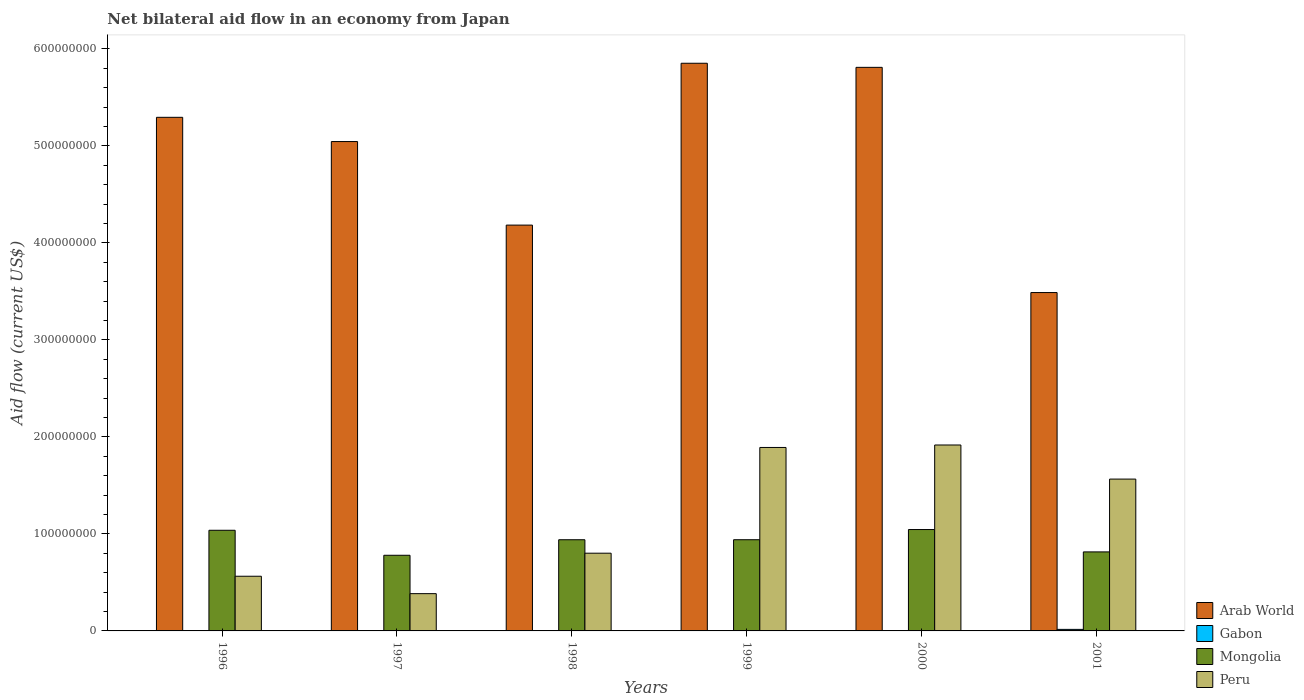How many different coloured bars are there?
Give a very brief answer. 4. How many groups of bars are there?
Offer a terse response. 6. Are the number of bars per tick equal to the number of legend labels?
Offer a very short reply. No. How many bars are there on the 6th tick from the left?
Keep it short and to the point. 4. What is the label of the 3rd group of bars from the left?
Keep it short and to the point. 1998. In how many cases, is the number of bars for a given year not equal to the number of legend labels?
Your answer should be compact. 1. What is the net bilateral aid flow in Mongolia in 1997?
Your answer should be compact. 7.80e+07. Across all years, what is the maximum net bilateral aid flow in Mongolia?
Offer a terse response. 1.05e+08. Across all years, what is the minimum net bilateral aid flow in Gabon?
Your answer should be very brief. 0. What is the total net bilateral aid flow in Gabon in the graph?
Offer a terse response. 2.82e+06. What is the difference between the net bilateral aid flow in Peru in 1997 and that in 2001?
Your response must be concise. -1.18e+08. What is the difference between the net bilateral aid flow in Peru in 1996 and the net bilateral aid flow in Mongolia in 1999?
Keep it short and to the point. -3.76e+07. In the year 1998, what is the difference between the net bilateral aid flow in Gabon and net bilateral aid flow in Arab World?
Offer a terse response. -4.18e+08. In how many years, is the net bilateral aid flow in Arab World greater than 400000000 US$?
Give a very brief answer. 5. What is the ratio of the net bilateral aid flow in Gabon in 1996 to that in 1997?
Your answer should be very brief. 0.62. Is the net bilateral aid flow in Arab World in 1998 less than that in 1999?
Provide a short and direct response. Yes. Is the difference between the net bilateral aid flow in Gabon in 1997 and 1999 greater than the difference between the net bilateral aid flow in Arab World in 1997 and 1999?
Your answer should be very brief. Yes. What is the difference between the highest and the second highest net bilateral aid flow in Gabon?
Keep it short and to the point. 1.19e+06. What is the difference between the highest and the lowest net bilateral aid flow in Mongolia?
Your response must be concise. 2.65e+07. Is it the case that in every year, the sum of the net bilateral aid flow in Mongolia and net bilateral aid flow in Arab World is greater than the sum of net bilateral aid flow in Gabon and net bilateral aid flow in Peru?
Offer a very short reply. No. Is it the case that in every year, the sum of the net bilateral aid flow in Gabon and net bilateral aid flow in Mongolia is greater than the net bilateral aid flow in Arab World?
Your response must be concise. No. How many bars are there?
Make the answer very short. 23. How many years are there in the graph?
Provide a short and direct response. 6. Does the graph contain grids?
Make the answer very short. No. Where does the legend appear in the graph?
Ensure brevity in your answer.  Bottom right. How many legend labels are there?
Your answer should be very brief. 4. What is the title of the graph?
Provide a short and direct response. Net bilateral aid flow in an economy from Japan. Does "Cabo Verde" appear as one of the legend labels in the graph?
Your answer should be compact. No. What is the label or title of the X-axis?
Keep it short and to the point. Years. What is the Aid flow (current US$) in Arab World in 1996?
Provide a succinct answer. 5.29e+08. What is the Aid flow (current US$) in Gabon in 1996?
Your answer should be compact. 2.40e+05. What is the Aid flow (current US$) of Mongolia in 1996?
Ensure brevity in your answer.  1.04e+08. What is the Aid flow (current US$) in Peru in 1996?
Give a very brief answer. 5.64e+07. What is the Aid flow (current US$) of Arab World in 1997?
Ensure brevity in your answer.  5.04e+08. What is the Aid flow (current US$) in Gabon in 1997?
Keep it short and to the point. 3.90e+05. What is the Aid flow (current US$) of Mongolia in 1997?
Keep it short and to the point. 7.80e+07. What is the Aid flow (current US$) in Peru in 1997?
Offer a terse response. 3.84e+07. What is the Aid flow (current US$) in Arab World in 1998?
Ensure brevity in your answer.  4.18e+08. What is the Aid flow (current US$) of Gabon in 1998?
Keep it short and to the point. 2.80e+05. What is the Aid flow (current US$) of Mongolia in 1998?
Keep it short and to the point. 9.40e+07. What is the Aid flow (current US$) of Peru in 1998?
Your answer should be very brief. 8.01e+07. What is the Aid flow (current US$) of Arab World in 1999?
Make the answer very short. 5.85e+08. What is the Aid flow (current US$) in Gabon in 1999?
Your answer should be very brief. 3.30e+05. What is the Aid flow (current US$) in Mongolia in 1999?
Ensure brevity in your answer.  9.40e+07. What is the Aid flow (current US$) in Peru in 1999?
Make the answer very short. 1.89e+08. What is the Aid flow (current US$) of Arab World in 2000?
Provide a succinct answer. 5.81e+08. What is the Aid flow (current US$) in Gabon in 2000?
Provide a short and direct response. 0. What is the Aid flow (current US$) of Mongolia in 2000?
Provide a succinct answer. 1.05e+08. What is the Aid flow (current US$) of Peru in 2000?
Give a very brief answer. 1.92e+08. What is the Aid flow (current US$) of Arab World in 2001?
Ensure brevity in your answer.  3.49e+08. What is the Aid flow (current US$) of Gabon in 2001?
Ensure brevity in your answer.  1.58e+06. What is the Aid flow (current US$) in Mongolia in 2001?
Keep it short and to the point. 8.15e+07. What is the Aid flow (current US$) in Peru in 2001?
Make the answer very short. 1.57e+08. Across all years, what is the maximum Aid flow (current US$) of Arab World?
Your answer should be very brief. 5.85e+08. Across all years, what is the maximum Aid flow (current US$) of Gabon?
Offer a very short reply. 1.58e+06. Across all years, what is the maximum Aid flow (current US$) of Mongolia?
Offer a terse response. 1.05e+08. Across all years, what is the maximum Aid flow (current US$) of Peru?
Provide a short and direct response. 1.92e+08. Across all years, what is the minimum Aid flow (current US$) in Arab World?
Your response must be concise. 3.49e+08. Across all years, what is the minimum Aid flow (current US$) of Mongolia?
Ensure brevity in your answer.  7.80e+07. Across all years, what is the minimum Aid flow (current US$) of Peru?
Offer a terse response. 3.84e+07. What is the total Aid flow (current US$) in Arab World in the graph?
Make the answer very short. 2.97e+09. What is the total Aid flow (current US$) of Gabon in the graph?
Make the answer very short. 2.82e+06. What is the total Aid flow (current US$) of Mongolia in the graph?
Your answer should be very brief. 5.56e+08. What is the total Aid flow (current US$) in Peru in the graph?
Provide a short and direct response. 7.12e+08. What is the difference between the Aid flow (current US$) in Arab World in 1996 and that in 1997?
Give a very brief answer. 2.50e+07. What is the difference between the Aid flow (current US$) of Gabon in 1996 and that in 1997?
Make the answer very short. -1.50e+05. What is the difference between the Aid flow (current US$) in Mongolia in 1996 and that in 1997?
Your answer should be very brief. 2.58e+07. What is the difference between the Aid flow (current US$) of Peru in 1996 and that in 1997?
Keep it short and to the point. 1.80e+07. What is the difference between the Aid flow (current US$) in Arab World in 1996 and that in 1998?
Provide a short and direct response. 1.11e+08. What is the difference between the Aid flow (current US$) in Mongolia in 1996 and that in 1998?
Make the answer very short. 9.76e+06. What is the difference between the Aid flow (current US$) in Peru in 1996 and that in 1998?
Offer a terse response. -2.38e+07. What is the difference between the Aid flow (current US$) of Arab World in 1996 and that in 1999?
Offer a very short reply. -5.57e+07. What is the difference between the Aid flow (current US$) of Gabon in 1996 and that in 1999?
Your answer should be compact. -9.00e+04. What is the difference between the Aid flow (current US$) in Mongolia in 1996 and that in 1999?
Your answer should be compact. 9.74e+06. What is the difference between the Aid flow (current US$) of Peru in 1996 and that in 1999?
Your answer should be compact. -1.33e+08. What is the difference between the Aid flow (current US$) in Arab World in 1996 and that in 2000?
Keep it short and to the point. -5.15e+07. What is the difference between the Aid flow (current US$) in Mongolia in 1996 and that in 2000?
Keep it short and to the point. -7.60e+05. What is the difference between the Aid flow (current US$) in Peru in 1996 and that in 2000?
Offer a very short reply. -1.35e+08. What is the difference between the Aid flow (current US$) in Arab World in 1996 and that in 2001?
Make the answer very short. 1.81e+08. What is the difference between the Aid flow (current US$) in Gabon in 1996 and that in 2001?
Give a very brief answer. -1.34e+06. What is the difference between the Aid flow (current US$) in Mongolia in 1996 and that in 2001?
Give a very brief answer. 2.23e+07. What is the difference between the Aid flow (current US$) of Peru in 1996 and that in 2001?
Ensure brevity in your answer.  -1.00e+08. What is the difference between the Aid flow (current US$) of Arab World in 1997 and that in 1998?
Your response must be concise. 8.61e+07. What is the difference between the Aid flow (current US$) of Gabon in 1997 and that in 1998?
Provide a short and direct response. 1.10e+05. What is the difference between the Aid flow (current US$) of Mongolia in 1997 and that in 1998?
Your response must be concise. -1.60e+07. What is the difference between the Aid flow (current US$) of Peru in 1997 and that in 1998?
Your answer should be very brief. -4.17e+07. What is the difference between the Aid flow (current US$) in Arab World in 1997 and that in 1999?
Keep it short and to the point. -8.07e+07. What is the difference between the Aid flow (current US$) of Mongolia in 1997 and that in 1999?
Provide a short and direct response. -1.60e+07. What is the difference between the Aid flow (current US$) in Peru in 1997 and that in 1999?
Keep it short and to the point. -1.51e+08. What is the difference between the Aid flow (current US$) of Arab World in 1997 and that in 2000?
Offer a terse response. -7.65e+07. What is the difference between the Aid flow (current US$) of Mongolia in 1997 and that in 2000?
Provide a succinct answer. -2.65e+07. What is the difference between the Aid flow (current US$) in Peru in 1997 and that in 2000?
Offer a terse response. -1.53e+08. What is the difference between the Aid flow (current US$) in Arab World in 1997 and that in 2001?
Make the answer very short. 1.56e+08. What is the difference between the Aid flow (current US$) in Gabon in 1997 and that in 2001?
Offer a very short reply. -1.19e+06. What is the difference between the Aid flow (current US$) in Mongolia in 1997 and that in 2001?
Your answer should be very brief. -3.48e+06. What is the difference between the Aid flow (current US$) in Peru in 1997 and that in 2001?
Provide a short and direct response. -1.18e+08. What is the difference between the Aid flow (current US$) in Arab World in 1998 and that in 1999?
Keep it short and to the point. -1.67e+08. What is the difference between the Aid flow (current US$) in Gabon in 1998 and that in 1999?
Offer a terse response. -5.00e+04. What is the difference between the Aid flow (current US$) in Peru in 1998 and that in 1999?
Offer a very short reply. -1.09e+08. What is the difference between the Aid flow (current US$) in Arab World in 1998 and that in 2000?
Provide a short and direct response. -1.63e+08. What is the difference between the Aid flow (current US$) of Mongolia in 1998 and that in 2000?
Offer a very short reply. -1.05e+07. What is the difference between the Aid flow (current US$) of Peru in 1998 and that in 2000?
Your answer should be very brief. -1.12e+08. What is the difference between the Aid flow (current US$) of Arab World in 1998 and that in 2001?
Your answer should be very brief. 6.95e+07. What is the difference between the Aid flow (current US$) of Gabon in 1998 and that in 2001?
Keep it short and to the point. -1.30e+06. What is the difference between the Aid flow (current US$) of Mongolia in 1998 and that in 2001?
Provide a short and direct response. 1.25e+07. What is the difference between the Aid flow (current US$) of Peru in 1998 and that in 2001?
Provide a short and direct response. -7.64e+07. What is the difference between the Aid flow (current US$) in Arab World in 1999 and that in 2000?
Offer a very short reply. 4.22e+06. What is the difference between the Aid flow (current US$) of Mongolia in 1999 and that in 2000?
Make the answer very short. -1.05e+07. What is the difference between the Aid flow (current US$) of Peru in 1999 and that in 2000?
Your answer should be very brief. -2.55e+06. What is the difference between the Aid flow (current US$) of Arab World in 1999 and that in 2001?
Your answer should be very brief. 2.36e+08. What is the difference between the Aid flow (current US$) of Gabon in 1999 and that in 2001?
Keep it short and to the point. -1.25e+06. What is the difference between the Aid flow (current US$) of Mongolia in 1999 and that in 2001?
Make the answer very short. 1.26e+07. What is the difference between the Aid flow (current US$) of Peru in 1999 and that in 2001?
Your response must be concise. 3.26e+07. What is the difference between the Aid flow (current US$) in Arab World in 2000 and that in 2001?
Keep it short and to the point. 2.32e+08. What is the difference between the Aid flow (current US$) in Mongolia in 2000 and that in 2001?
Provide a short and direct response. 2.30e+07. What is the difference between the Aid flow (current US$) of Peru in 2000 and that in 2001?
Make the answer very short. 3.52e+07. What is the difference between the Aid flow (current US$) of Arab World in 1996 and the Aid flow (current US$) of Gabon in 1997?
Offer a very short reply. 5.29e+08. What is the difference between the Aid flow (current US$) of Arab World in 1996 and the Aid flow (current US$) of Mongolia in 1997?
Provide a short and direct response. 4.51e+08. What is the difference between the Aid flow (current US$) of Arab World in 1996 and the Aid flow (current US$) of Peru in 1997?
Keep it short and to the point. 4.91e+08. What is the difference between the Aid flow (current US$) of Gabon in 1996 and the Aid flow (current US$) of Mongolia in 1997?
Provide a succinct answer. -7.77e+07. What is the difference between the Aid flow (current US$) of Gabon in 1996 and the Aid flow (current US$) of Peru in 1997?
Provide a short and direct response. -3.82e+07. What is the difference between the Aid flow (current US$) in Mongolia in 1996 and the Aid flow (current US$) in Peru in 1997?
Keep it short and to the point. 6.53e+07. What is the difference between the Aid flow (current US$) in Arab World in 1996 and the Aid flow (current US$) in Gabon in 1998?
Provide a succinct answer. 5.29e+08. What is the difference between the Aid flow (current US$) in Arab World in 1996 and the Aid flow (current US$) in Mongolia in 1998?
Provide a short and direct response. 4.35e+08. What is the difference between the Aid flow (current US$) of Arab World in 1996 and the Aid flow (current US$) of Peru in 1998?
Provide a short and direct response. 4.49e+08. What is the difference between the Aid flow (current US$) in Gabon in 1996 and the Aid flow (current US$) in Mongolia in 1998?
Ensure brevity in your answer.  -9.38e+07. What is the difference between the Aid flow (current US$) in Gabon in 1996 and the Aid flow (current US$) in Peru in 1998?
Provide a short and direct response. -7.99e+07. What is the difference between the Aid flow (current US$) of Mongolia in 1996 and the Aid flow (current US$) of Peru in 1998?
Your response must be concise. 2.36e+07. What is the difference between the Aid flow (current US$) of Arab World in 1996 and the Aid flow (current US$) of Gabon in 1999?
Your answer should be compact. 5.29e+08. What is the difference between the Aid flow (current US$) in Arab World in 1996 and the Aid flow (current US$) in Mongolia in 1999?
Provide a succinct answer. 4.35e+08. What is the difference between the Aid flow (current US$) in Arab World in 1996 and the Aid flow (current US$) in Peru in 1999?
Offer a terse response. 3.40e+08. What is the difference between the Aid flow (current US$) in Gabon in 1996 and the Aid flow (current US$) in Mongolia in 1999?
Your answer should be compact. -9.38e+07. What is the difference between the Aid flow (current US$) in Gabon in 1996 and the Aid flow (current US$) in Peru in 1999?
Your answer should be very brief. -1.89e+08. What is the difference between the Aid flow (current US$) in Mongolia in 1996 and the Aid flow (current US$) in Peru in 1999?
Your answer should be compact. -8.54e+07. What is the difference between the Aid flow (current US$) of Arab World in 1996 and the Aid flow (current US$) of Mongolia in 2000?
Your response must be concise. 4.25e+08. What is the difference between the Aid flow (current US$) in Arab World in 1996 and the Aid flow (current US$) in Peru in 2000?
Keep it short and to the point. 3.38e+08. What is the difference between the Aid flow (current US$) of Gabon in 1996 and the Aid flow (current US$) of Mongolia in 2000?
Ensure brevity in your answer.  -1.04e+08. What is the difference between the Aid flow (current US$) of Gabon in 1996 and the Aid flow (current US$) of Peru in 2000?
Offer a very short reply. -1.91e+08. What is the difference between the Aid flow (current US$) in Mongolia in 1996 and the Aid flow (current US$) in Peru in 2000?
Ensure brevity in your answer.  -8.79e+07. What is the difference between the Aid flow (current US$) in Arab World in 1996 and the Aid flow (current US$) in Gabon in 2001?
Offer a very short reply. 5.28e+08. What is the difference between the Aid flow (current US$) in Arab World in 1996 and the Aid flow (current US$) in Mongolia in 2001?
Keep it short and to the point. 4.48e+08. What is the difference between the Aid flow (current US$) in Arab World in 1996 and the Aid flow (current US$) in Peru in 2001?
Give a very brief answer. 3.73e+08. What is the difference between the Aid flow (current US$) of Gabon in 1996 and the Aid flow (current US$) of Mongolia in 2001?
Give a very brief answer. -8.12e+07. What is the difference between the Aid flow (current US$) of Gabon in 1996 and the Aid flow (current US$) of Peru in 2001?
Provide a succinct answer. -1.56e+08. What is the difference between the Aid flow (current US$) in Mongolia in 1996 and the Aid flow (current US$) in Peru in 2001?
Provide a succinct answer. -5.28e+07. What is the difference between the Aid flow (current US$) in Arab World in 1997 and the Aid flow (current US$) in Gabon in 1998?
Make the answer very short. 5.04e+08. What is the difference between the Aid flow (current US$) in Arab World in 1997 and the Aid flow (current US$) in Mongolia in 1998?
Make the answer very short. 4.10e+08. What is the difference between the Aid flow (current US$) of Arab World in 1997 and the Aid flow (current US$) of Peru in 1998?
Offer a terse response. 4.24e+08. What is the difference between the Aid flow (current US$) of Gabon in 1997 and the Aid flow (current US$) of Mongolia in 1998?
Your answer should be very brief. -9.36e+07. What is the difference between the Aid flow (current US$) in Gabon in 1997 and the Aid flow (current US$) in Peru in 1998?
Ensure brevity in your answer.  -7.97e+07. What is the difference between the Aid flow (current US$) of Mongolia in 1997 and the Aid flow (current US$) of Peru in 1998?
Provide a succinct answer. -2.15e+06. What is the difference between the Aid flow (current US$) in Arab World in 1997 and the Aid flow (current US$) in Gabon in 1999?
Keep it short and to the point. 5.04e+08. What is the difference between the Aid flow (current US$) in Arab World in 1997 and the Aid flow (current US$) in Mongolia in 1999?
Make the answer very short. 4.10e+08. What is the difference between the Aid flow (current US$) in Arab World in 1997 and the Aid flow (current US$) in Peru in 1999?
Offer a very short reply. 3.15e+08. What is the difference between the Aid flow (current US$) of Gabon in 1997 and the Aid flow (current US$) of Mongolia in 1999?
Offer a terse response. -9.36e+07. What is the difference between the Aid flow (current US$) of Gabon in 1997 and the Aid flow (current US$) of Peru in 1999?
Your answer should be compact. -1.89e+08. What is the difference between the Aid flow (current US$) in Mongolia in 1997 and the Aid flow (current US$) in Peru in 1999?
Keep it short and to the point. -1.11e+08. What is the difference between the Aid flow (current US$) of Arab World in 1997 and the Aid flow (current US$) of Mongolia in 2000?
Offer a very short reply. 4.00e+08. What is the difference between the Aid flow (current US$) of Arab World in 1997 and the Aid flow (current US$) of Peru in 2000?
Make the answer very short. 3.13e+08. What is the difference between the Aid flow (current US$) in Gabon in 1997 and the Aid flow (current US$) in Mongolia in 2000?
Offer a very short reply. -1.04e+08. What is the difference between the Aid flow (current US$) in Gabon in 1997 and the Aid flow (current US$) in Peru in 2000?
Provide a short and direct response. -1.91e+08. What is the difference between the Aid flow (current US$) in Mongolia in 1997 and the Aid flow (current US$) in Peru in 2000?
Your answer should be compact. -1.14e+08. What is the difference between the Aid flow (current US$) in Arab World in 1997 and the Aid flow (current US$) in Gabon in 2001?
Offer a terse response. 5.03e+08. What is the difference between the Aid flow (current US$) of Arab World in 1997 and the Aid flow (current US$) of Mongolia in 2001?
Your answer should be compact. 4.23e+08. What is the difference between the Aid flow (current US$) in Arab World in 1997 and the Aid flow (current US$) in Peru in 2001?
Provide a succinct answer. 3.48e+08. What is the difference between the Aid flow (current US$) of Gabon in 1997 and the Aid flow (current US$) of Mongolia in 2001?
Offer a very short reply. -8.11e+07. What is the difference between the Aid flow (current US$) in Gabon in 1997 and the Aid flow (current US$) in Peru in 2001?
Your answer should be compact. -1.56e+08. What is the difference between the Aid flow (current US$) of Mongolia in 1997 and the Aid flow (current US$) of Peru in 2001?
Provide a short and direct response. -7.85e+07. What is the difference between the Aid flow (current US$) in Arab World in 1998 and the Aid flow (current US$) in Gabon in 1999?
Offer a very short reply. 4.18e+08. What is the difference between the Aid flow (current US$) of Arab World in 1998 and the Aid flow (current US$) of Mongolia in 1999?
Offer a very short reply. 3.24e+08. What is the difference between the Aid flow (current US$) of Arab World in 1998 and the Aid flow (current US$) of Peru in 1999?
Your answer should be compact. 2.29e+08. What is the difference between the Aid flow (current US$) in Gabon in 1998 and the Aid flow (current US$) in Mongolia in 1999?
Ensure brevity in your answer.  -9.37e+07. What is the difference between the Aid flow (current US$) in Gabon in 1998 and the Aid flow (current US$) in Peru in 1999?
Make the answer very short. -1.89e+08. What is the difference between the Aid flow (current US$) of Mongolia in 1998 and the Aid flow (current US$) of Peru in 1999?
Give a very brief answer. -9.51e+07. What is the difference between the Aid flow (current US$) of Arab World in 1998 and the Aid flow (current US$) of Mongolia in 2000?
Your answer should be very brief. 3.14e+08. What is the difference between the Aid flow (current US$) in Arab World in 1998 and the Aid flow (current US$) in Peru in 2000?
Give a very brief answer. 2.27e+08. What is the difference between the Aid flow (current US$) of Gabon in 1998 and the Aid flow (current US$) of Mongolia in 2000?
Offer a terse response. -1.04e+08. What is the difference between the Aid flow (current US$) in Gabon in 1998 and the Aid flow (current US$) in Peru in 2000?
Give a very brief answer. -1.91e+08. What is the difference between the Aid flow (current US$) in Mongolia in 1998 and the Aid flow (current US$) in Peru in 2000?
Make the answer very short. -9.77e+07. What is the difference between the Aid flow (current US$) of Arab World in 1998 and the Aid flow (current US$) of Gabon in 2001?
Make the answer very short. 4.17e+08. What is the difference between the Aid flow (current US$) in Arab World in 1998 and the Aid flow (current US$) in Mongolia in 2001?
Make the answer very short. 3.37e+08. What is the difference between the Aid flow (current US$) in Arab World in 1998 and the Aid flow (current US$) in Peru in 2001?
Your response must be concise. 2.62e+08. What is the difference between the Aid flow (current US$) of Gabon in 1998 and the Aid flow (current US$) of Mongolia in 2001?
Provide a succinct answer. -8.12e+07. What is the difference between the Aid flow (current US$) of Gabon in 1998 and the Aid flow (current US$) of Peru in 2001?
Keep it short and to the point. -1.56e+08. What is the difference between the Aid flow (current US$) of Mongolia in 1998 and the Aid flow (current US$) of Peru in 2001?
Provide a succinct answer. -6.25e+07. What is the difference between the Aid flow (current US$) in Arab World in 1999 and the Aid flow (current US$) in Mongolia in 2000?
Make the answer very short. 4.81e+08. What is the difference between the Aid flow (current US$) in Arab World in 1999 and the Aid flow (current US$) in Peru in 2000?
Ensure brevity in your answer.  3.94e+08. What is the difference between the Aid flow (current US$) in Gabon in 1999 and the Aid flow (current US$) in Mongolia in 2000?
Offer a very short reply. -1.04e+08. What is the difference between the Aid flow (current US$) in Gabon in 1999 and the Aid flow (current US$) in Peru in 2000?
Offer a very short reply. -1.91e+08. What is the difference between the Aid flow (current US$) of Mongolia in 1999 and the Aid flow (current US$) of Peru in 2000?
Offer a terse response. -9.77e+07. What is the difference between the Aid flow (current US$) in Arab World in 1999 and the Aid flow (current US$) in Gabon in 2001?
Your answer should be compact. 5.84e+08. What is the difference between the Aid flow (current US$) in Arab World in 1999 and the Aid flow (current US$) in Mongolia in 2001?
Offer a terse response. 5.04e+08. What is the difference between the Aid flow (current US$) in Arab World in 1999 and the Aid flow (current US$) in Peru in 2001?
Keep it short and to the point. 4.29e+08. What is the difference between the Aid flow (current US$) of Gabon in 1999 and the Aid flow (current US$) of Mongolia in 2001?
Your response must be concise. -8.11e+07. What is the difference between the Aid flow (current US$) in Gabon in 1999 and the Aid flow (current US$) in Peru in 2001?
Offer a very short reply. -1.56e+08. What is the difference between the Aid flow (current US$) of Mongolia in 1999 and the Aid flow (current US$) of Peru in 2001?
Keep it short and to the point. -6.25e+07. What is the difference between the Aid flow (current US$) of Arab World in 2000 and the Aid flow (current US$) of Gabon in 2001?
Offer a terse response. 5.79e+08. What is the difference between the Aid flow (current US$) of Arab World in 2000 and the Aid flow (current US$) of Mongolia in 2001?
Your answer should be very brief. 5.00e+08. What is the difference between the Aid flow (current US$) of Arab World in 2000 and the Aid flow (current US$) of Peru in 2001?
Offer a terse response. 4.24e+08. What is the difference between the Aid flow (current US$) of Mongolia in 2000 and the Aid flow (current US$) of Peru in 2001?
Offer a very short reply. -5.20e+07. What is the average Aid flow (current US$) in Arab World per year?
Provide a succinct answer. 4.95e+08. What is the average Aid flow (current US$) in Mongolia per year?
Provide a succinct answer. 9.26e+07. What is the average Aid flow (current US$) in Peru per year?
Make the answer very short. 1.19e+08. In the year 1996, what is the difference between the Aid flow (current US$) of Arab World and Aid flow (current US$) of Gabon?
Your answer should be very brief. 5.29e+08. In the year 1996, what is the difference between the Aid flow (current US$) of Arab World and Aid flow (current US$) of Mongolia?
Provide a short and direct response. 4.26e+08. In the year 1996, what is the difference between the Aid flow (current US$) of Arab World and Aid flow (current US$) of Peru?
Make the answer very short. 4.73e+08. In the year 1996, what is the difference between the Aid flow (current US$) of Gabon and Aid flow (current US$) of Mongolia?
Your response must be concise. -1.04e+08. In the year 1996, what is the difference between the Aid flow (current US$) of Gabon and Aid flow (current US$) of Peru?
Keep it short and to the point. -5.61e+07. In the year 1996, what is the difference between the Aid flow (current US$) of Mongolia and Aid flow (current US$) of Peru?
Your response must be concise. 4.74e+07. In the year 1997, what is the difference between the Aid flow (current US$) in Arab World and Aid flow (current US$) in Gabon?
Offer a very short reply. 5.04e+08. In the year 1997, what is the difference between the Aid flow (current US$) of Arab World and Aid flow (current US$) of Mongolia?
Provide a succinct answer. 4.27e+08. In the year 1997, what is the difference between the Aid flow (current US$) of Arab World and Aid flow (current US$) of Peru?
Offer a terse response. 4.66e+08. In the year 1997, what is the difference between the Aid flow (current US$) in Gabon and Aid flow (current US$) in Mongolia?
Your answer should be compact. -7.76e+07. In the year 1997, what is the difference between the Aid flow (current US$) of Gabon and Aid flow (current US$) of Peru?
Ensure brevity in your answer.  -3.80e+07. In the year 1997, what is the difference between the Aid flow (current US$) in Mongolia and Aid flow (current US$) in Peru?
Keep it short and to the point. 3.96e+07. In the year 1998, what is the difference between the Aid flow (current US$) of Arab World and Aid flow (current US$) of Gabon?
Your answer should be very brief. 4.18e+08. In the year 1998, what is the difference between the Aid flow (current US$) in Arab World and Aid flow (current US$) in Mongolia?
Your response must be concise. 3.24e+08. In the year 1998, what is the difference between the Aid flow (current US$) of Arab World and Aid flow (current US$) of Peru?
Provide a succinct answer. 3.38e+08. In the year 1998, what is the difference between the Aid flow (current US$) of Gabon and Aid flow (current US$) of Mongolia?
Keep it short and to the point. -9.37e+07. In the year 1998, what is the difference between the Aid flow (current US$) of Gabon and Aid flow (current US$) of Peru?
Offer a terse response. -7.98e+07. In the year 1998, what is the difference between the Aid flow (current US$) of Mongolia and Aid flow (current US$) of Peru?
Offer a very short reply. 1.39e+07. In the year 1999, what is the difference between the Aid flow (current US$) of Arab World and Aid flow (current US$) of Gabon?
Offer a very short reply. 5.85e+08. In the year 1999, what is the difference between the Aid flow (current US$) of Arab World and Aid flow (current US$) of Mongolia?
Ensure brevity in your answer.  4.91e+08. In the year 1999, what is the difference between the Aid flow (current US$) of Arab World and Aid flow (current US$) of Peru?
Your answer should be very brief. 3.96e+08. In the year 1999, what is the difference between the Aid flow (current US$) in Gabon and Aid flow (current US$) in Mongolia?
Your response must be concise. -9.37e+07. In the year 1999, what is the difference between the Aid flow (current US$) of Gabon and Aid flow (current US$) of Peru?
Ensure brevity in your answer.  -1.89e+08. In the year 1999, what is the difference between the Aid flow (current US$) of Mongolia and Aid flow (current US$) of Peru?
Make the answer very short. -9.51e+07. In the year 2000, what is the difference between the Aid flow (current US$) in Arab World and Aid flow (current US$) in Mongolia?
Ensure brevity in your answer.  4.76e+08. In the year 2000, what is the difference between the Aid flow (current US$) in Arab World and Aid flow (current US$) in Peru?
Offer a very short reply. 3.89e+08. In the year 2000, what is the difference between the Aid flow (current US$) of Mongolia and Aid flow (current US$) of Peru?
Keep it short and to the point. -8.72e+07. In the year 2001, what is the difference between the Aid flow (current US$) in Arab World and Aid flow (current US$) in Gabon?
Your response must be concise. 3.47e+08. In the year 2001, what is the difference between the Aid flow (current US$) of Arab World and Aid flow (current US$) of Mongolia?
Provide a succinct answer. 2.67e+08. In the year 2001, what is the difference between the Aid flow (current US$) in Arab World and Aid flow (current US$) in Peru?
Offer a terse response. 1.92e+08. In the year 2001, what is the difference between the Aid flow (current US$) in Gabon and Aid flow (current US$) in Mongolia?
Make the answer very short. -7.99e+07. In the year 2001, what is the difference between the Aid flow (current US$) of Gabon and Aid flow (current US$) of Peru?
Provide a succinct answer. -1.55e+08. In the year 2001, what is the difference between the Aid flow (current US$) in Mongolia and Aid flow (current US$) in Peru?
Make the answer very short. -7.51e+07. What is the ratio of the Aid flow (current US$) in Arab World in 1996 to that in 1997?
Offer a very short reply. 1.05. What is the ratio of the Aid flow (current US$) in Gabon in 1996 to that in 1997?
Make the answer very short. 0.62. What is the ratio of the Aid flow (current US$) in Mongolia in 1996 to that in 1997?
Your answer should be compact. 1.33. What is the ratio of the Aid flow (current US$) in Peru in 1996 to that in 1997?
Ensure brevity in your answer.  1.47. What is the ratio of the Aid flow (current US$) in Arab World in 1996 to that in 1998?
Keep it short and to the point. 1.27. What is the ratio of the Aid flow (current US$) in Gabon in 1996 to that in 1998?
Your response must be concise. 0.86. What is the ratio of the Aid flow (current US$) in Mongolia in 1996 to that in 1998?
Provide a succinct answer. 1.1. What is the ratio of the Aid flow (current US$) of Peru in 1996 to that in 1998?
Make the answer very short. 0.7. What is the ratio of the Aid flow (current US$) in Arab World in 1996 to that in 1999?
Offer a terse response. 0.9. What is the ratio of the Aid flow (current US$) in Gabon in 1996 to that in 1999?
Offer a very short reply. 0.73. What is the ratio of the Aid flow (current US$) in Mongolia in 1996 to that in 1999?
Your response must be concise. 1.1. What is the ratio of the Aid flow (current US$) in Peru in 1996 to that in 1999?
Offer a very short reply. 0.3. What is the ratio of the Aid flow (current US$) of Arab World in 1996 to that in 2000?
Your answer should be very brief. 0.91. What is the ratio of the Aid flow (current US$) in Mongolia in 1996 to that in 2000?
Your answer should be compact. 0.99. What is the ratio of the Aid flow (current US$) in Peru in 1996 to that in 2000?
Offer a terse response. 0.29. What is the ratio of the Aid flow (current US$) of Arab World in 1996 to that in 2001?
Ensure brevity in your answer.  1.52. What is the ratio of the Aid flow (current US$) in Gabon in 1996 to that in 2001?
Provide a succinct answer. 0.15. What is the ratio of the Aid flow (current US$) in Mongolia in 1996 to that in 2001?
Ensure brevity in your answer.  1.27. What is the ratio of the Aid flow (current US$) in Peru in 1996 to that in 2001?
Make the answer very short. 0.36. What is the ratio of the Aid flow (current US$) in Arab World in 1997 to that in 1998?
Offer a terse response. 1.21. What is the ratio of the Aid flow (current US$) of Gabon in 1997 to that in 1998?
Your response must be concise. 1.39. What is the ratio of the Aid flow (current US$) in Mongolia in 1997 to that in 1998?
Make the answer very short. 0.83. What is the ratio of the Aid flow (current US$) in Peru in 1997 to that in 1998?
Provide a succinct answer. 0.48. What is the ratio of the Aid flow (current US$) in Arab World in 1997 to that in 1999?
Ensure brevity in your answer.  0.86. What is the ratio of the Aid flow (current US$) in Gabon in 1997 to that in 1999?
Make the answer very short. 1.18. What is the ratio of the Aid flow (current US$) of Mongolia in 1997 to that in 1999?
Your answer should be very brief. 0.83. What is the ratio of the Aid flow (current US$) of Peru in 1997 to that in 1999?
Your answer should be compact. 0.2. What is the ratio of the Aid flow (current US$) in Arab World in 1997 to that in 2000?
Give a very brief answer. 0.87. What is the ratio of the Aid flow (current US$) of Mongolia in 1997 to that in 2000?
Your answer should be very brief. 0.75. What is the ratio of the Aid flow (current US$) in Peru in 1997 to that in 2000?
Offer a terse response. 0.2. What is the ratio of the Aid flow (current US$) in Arab World in 1997 to that in 2001?
Offer a very short reply. 1.45. What is the ratio of the Aid flow (current US$) of Gabon in 1997 to that in 2001?
Keep it short and to the point. 0.25. What is the ratio of the Aid flow (current US$) of Mongolia in 1997 to that in 2001?
Your answer should be compact. 0.96. What is the ratio of the Aid flow (current US$) of Peru in 1997 to that in 2001?
Your response must be concise. 0.25. What is the ratio of the Aid flow (current US$) of Arab World in 1998 to that in 1999?
Offer a very short reply. 0.71. What is the ratio of the Aid flow (current US$) in Gabon in 1998 to that in 1999?
Your response must be concise. 0.85. What is the ratio of the Aid flow (current US$) of Peru in 1998 to that in 1999?
Provide a succinct answer. 0.42. What is the ratio of the Aid flow (current US$) in Arab World in 1998 to that in 2000?
Your answer should be very brief. 0.72. What is the ratio of the Aid flow (current US$) in Mongolia in 1998 to that in 2000?
Provide a succinct answer. 0.9. What is the ratio of the Aid flow (current US$) in Peru in 1998 to that in 2000?
Give a very brief answer. 0.42. What is the ratio of the Aid flow (current US$) in Arab World in 1998 to that in 2001?
Offer a terse response. 1.2. What is the ratio of the Aid flow (current US$) in Gabon in 1998 to that in 2001?
Give a very brief answer. 0.18. What is the ratio of the Aid flow (current US$) of Mongolia in 1998 to that in 2001?
Keep it short and to the point. 1.15. What is the ratio of the Aid flow (current US$) of Peru in 1998 to that in 2001?
Make the answer very short. 0.51. What is the ratio of the Aid flow (current US$) of Arab World in 1999 to that in 2000?
Keep it short and to the point. 1.01. What is the ratio of the Aid flow (current US$) of Mongolia in 1999 to that in 2000?
Your response must be concise. 0.9. What is the ratio of the Aid flow (current US$) in Peru in 1999 to that in 2000?
Offer a terse response. 0.99. What is the ratio of the Aid flow (current US$) of Arab World in 1999 to that in 2001?
Your response must be concise. 1.68. What is the ratio of the Aid flow (current US$) in Gabon in 1999 to that in 2001?
Keep it short and to the point. 0.21. What is the ratio of the Aid flow (current US$) of Mongolia in 1999 to that in 2001?
Provide a short and direct response. 1.15. What is the ratio of the Aid flow (current US$) in Peru in 1999 to that in 2001?
Your response must be concise. 1.21. What is the ratio of the Aid flow (current US$) of Arab World in 2000 to that in 2001?
Provide a short and direct response. 1.67. What is the ratio of the Aid flow (current US$) of Mongolia in 2000 to that in 2001?
Give a very brief answer. 1.28. What is the ratio of the Aid flow (current US$) in Peru in 2000 to that in 2001?
Your answer should be very brief. 1.22. What is the difference between the highest and the second highest Aid flow (current US$) of Arab World?
Offer a very short reply. 4.22e+06. What is the difference between the highest and the second highest Aid flow (current US$) of Gabon?
Provide a short and direct response. 1.19e+06. What is the difference between the highest and the second highest Aid flow (current US$) of Mongolia?
Ensure brevity in your answer.  7.60e+05. What is the difference between the highest and the second highest Aid flow (current US$) of Peru?
Your answer should be compact. 2.55e+06. What is the difference between the highest and the lowest Aid flow (current US$) in Arab World?
Your answer should be very brief. 2.36e+08. What is the difference between the highest and the lowest Aid flow (current US$) in Gabon?
Your response must be concise. 1.58e+06. What is the difference between the highest and the lowest Aid flow (current US$) in Mongolia?
Provide a succinct answer. 2.65e+07. What is the difference between the highest and the lowest Aid flow (current US$) of Peru?
Provide a succinct answer. 1.53e+08. 